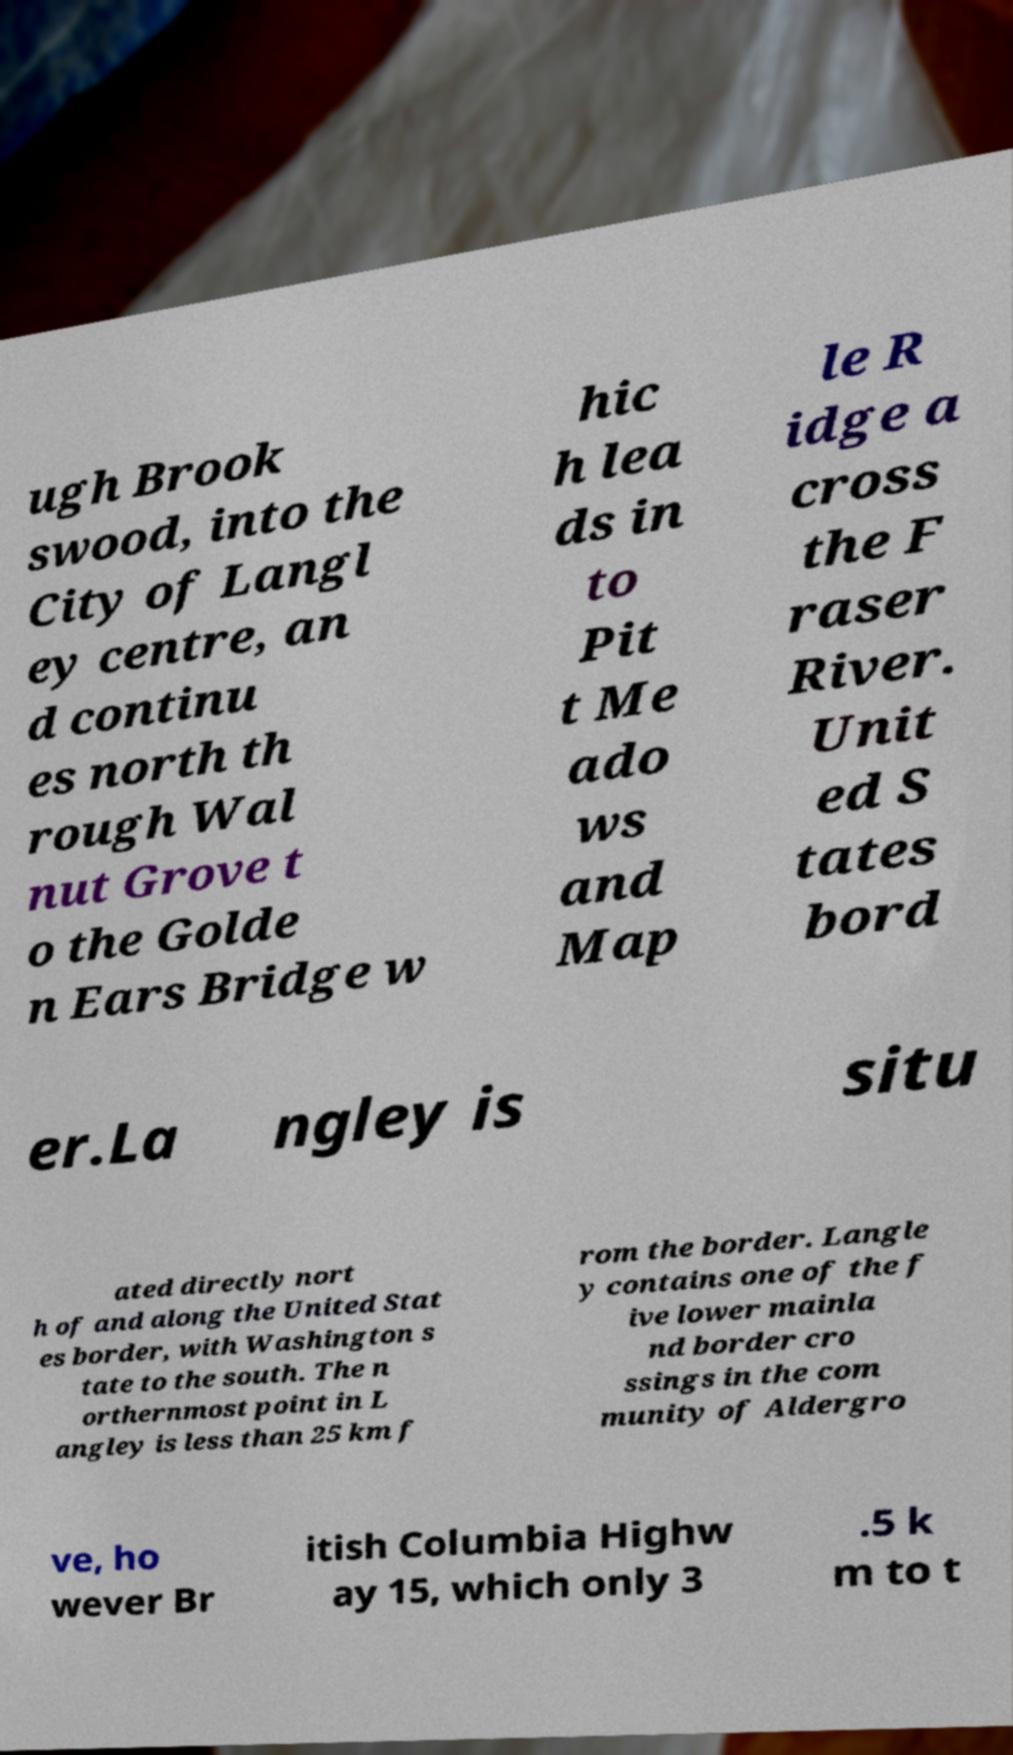I need the written content from this picture converted into text. Can you do that? ugh Brook swood, into the City of Langl ey centre, an d continu es north th rough Wal nut Grove t o the Golde n Ears Bridge w hic h lea ds in to Pit t Me ado ws and Map le R idge a cross the F raser River. Unit ed S tates bord er.La ngley is situ ated directly nort h of and along the United Stat es border, with Washington s tate to the south. The n orthernmost point in L angley is less than 25 km f rom the border. Langle y contains one of the f ive lower mainla nd border cro ssings in the com munity of Aldergro ve, ho wever Br itish Columbia Highw ay 15, which only 3 .5 k m to t 